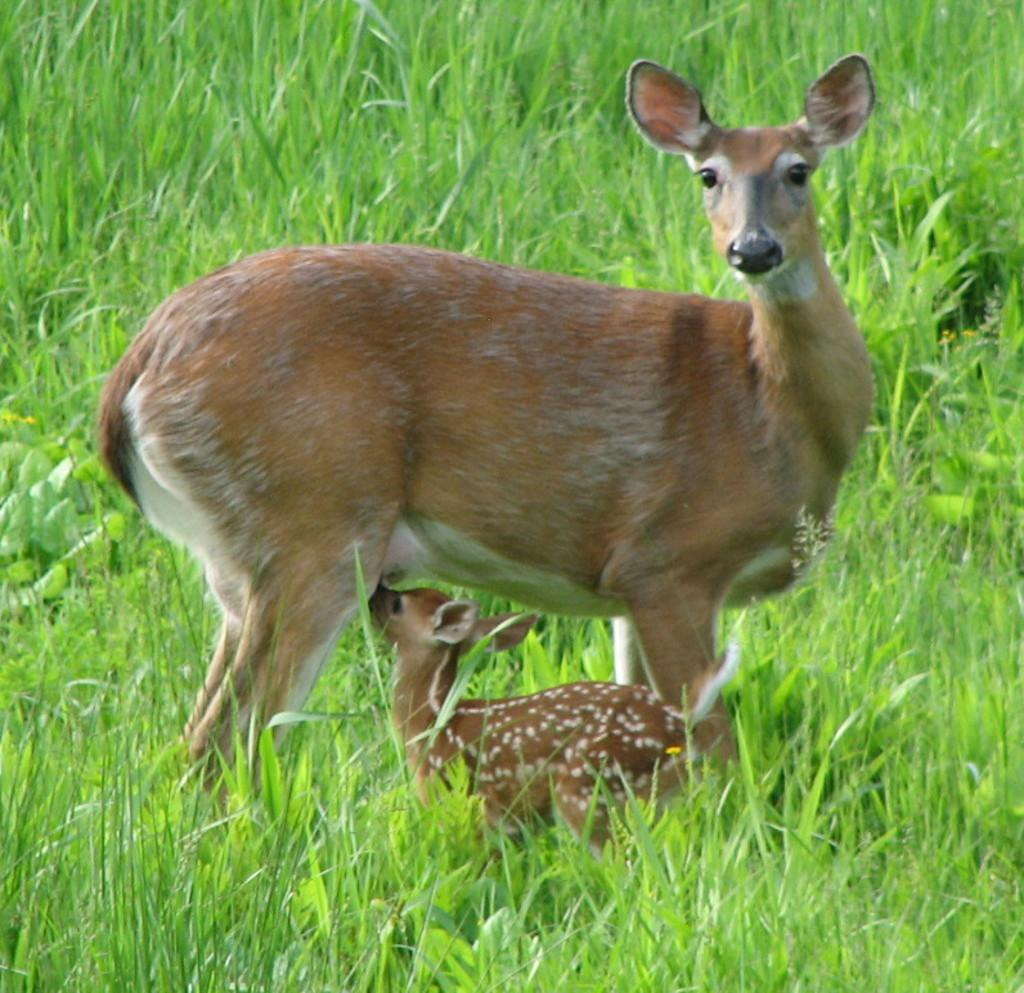What type of animal can be seen in the image? There is a deer in the image. Can you identify any other animals in the image? Yes, there is a fawn in the image. What type of vegetation is visible in the background of the image? There is grass in the background of the image. Where might this image have been taken? The image might have been taken in a zoo. What type of balls are being played with by the deer in the image? There are no balls present in the image; it features a deer and a fawn in a grassy setting. 